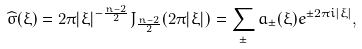Convert formula to latex. <formula><loc_0><loc_0><loc_500><loc_500>\widehat { \sigma } ( \xi ) = 2 \pi | \xi | ^ { - \frac { n - 2 } { 2 } } J _ { \frac { n - 2 } { 2 } } ( 2 \pi | \xi | ) = \sum _ { \pm } a _ { \pm } ( \xi ) e ^ { \pm 2 \pi i | \xi | } ,</formula> 